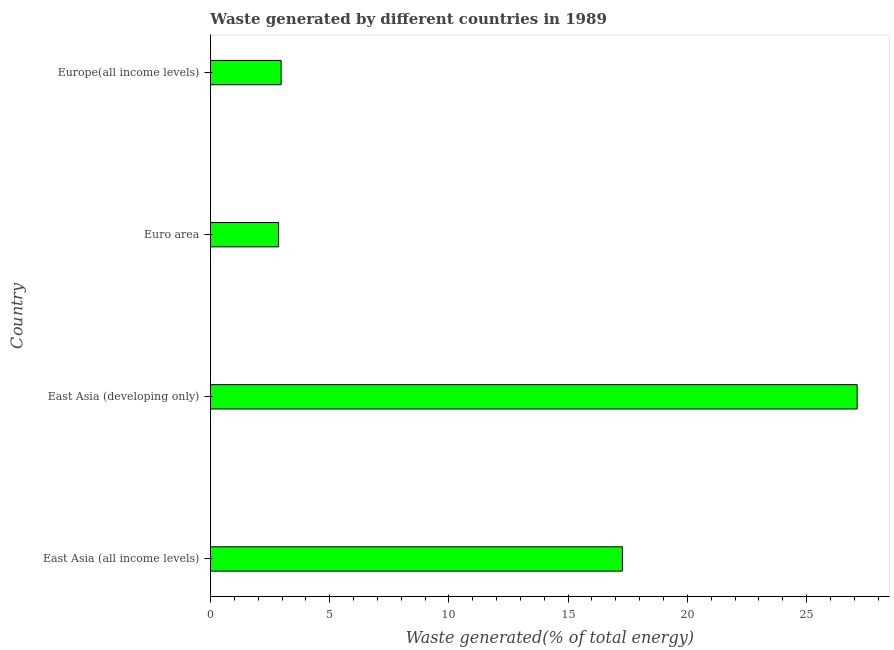Does the graph contain any zero values?
Keep it short and to the point. No. What is the title of the graph?
Keep it short and to the point. Waste generated by different countries in 1989. What is the label or title of the X-axis?
Ensure brevity in your answer.  Waste generated(% of total energy). What is the label or title of the Y-axis?
Offer a very short reply. Country. What is the amount of waste generated in East Asia (developing only)?
Offer a terse response. 27.12. Across all countries, what is the maximum amount of waste generated?
Keep it short and to the point. 27.12. Across all countries, what is the minimum amount of waste generated?
Your answer should be very brief. 2.86. In which country was the amount of waste generated maximum?
Offer a very short reply. East Asia (developing only). In which country was the amount of waste generated minimum?
Keep it short and to the point. Euro area. What is the sum of the amount of waste generated?
Give a very brief answer. 50.22. What is the difference between the amount of waste generated in East Asia (developing only) and Europe(all income levels)?
Keep it short and to the point. 24.16. What is the average amount of waste generated per country?
Ensure brevity in your answer.  12.55. What is the median amount of waste generated?
Ensure brevity in your answer.  10.12. What is the ratio of the amount of waste generated in East Asia (developing only) to that in Europe(all income levels)?
Ensure brevity in your answer.  9.15. Is the difference between the amount of waste generated in East Asia (all income levels) and Europe(all income levels) greater than the difference between any two countries?
Your answer should be compact. No. What is the difference between the highest and the second highest amount of waste generated?
Ensure brevity in your answer.  9.84. Is the sum of the amount of waste generated in East Asia (all income levels) and East Asia (developing only) greater than the maximum amount of waste generated across all countries?
Provide a short and direct response. Yes. What is the difference between the highest and the lowest amount of waste generated?
Give a very brief answer. 24.26. In how many countries, is the amount of waste generated greater than the average amount of waste generated taken over all countries?
Make the answer very short. 2. How many countries are there in the graph?
Your response must be concise. 4. What is the Waste generated(% of total energy) of East Asia (all income levels)?
Your answer should be compact. 17.28. What is the Waste generated(% of total energy) of East Asia (developing only)?
Make the answer very short. 27.12. What is the Waste generated(% of total energy) of Euro area?
Your answer should be very brief. 2.86. What is the Waste generated(% of total energy) in Europe(all income levels)?
Make the answer very short. 2.96. What is the difference between the Waste generated(% of total energy) in East Asia (all income levels) and East Asia (developing only)?
Offer a terse response. -9.84. What is the difference between the Waste generated(% of total energy) in East Asia (all income levels) and Euro area?
Offer a terse response. 14.42. What is the difference between the Waste generated(% of total energy) in East Asia (all income levels) and Europe(all income levels)?
Keep it short and to the point. 14.31. What is the difference between the Waste generated(% of total energy) in East Asia (developing only) and Euro area?
Provide a succinct answer. 24.26. What is the difference between the Waste generated(% of total energy) in East Asia (developing only) and Europe(all income levels)?
Provide a succinct answer. 24.16. What is the difference between the Waste generated(% of total energy) in Euro area and Europe(all income levels)?
Give a very brief answer. -0.1. What is the ratio of the Waste generated(% of total energy) in East Asia (all income levels) to that in East Asia (developing only)?
Offer a very short reply. 0.64. What is the ratio of the Waste generated(% of total energy) in East Asia (all income levels) to that in Euro area?
Your answer should be compact. 6.05. What is the ratio of the Waste generated(% of total energy) in East Asia (all income levels) to that in Europe(all income levels)?
Provide a succinct answer. 5.83. What is the ratio of the Waste generated(% of total energy) in East Asia (developing only) to that in Euro area?
Give a very brief answer. 9.49. What is the ratio of the Waste generated(% of total energy) in East Asia (developing only) to that in Europe(all income levels)?
Offer a very short reply. 9.15. What is the ratio of the Waste generated(% of total energy) in Euro area to that in Europe(all income levels)?
Offer a very short reply. 0.96. 